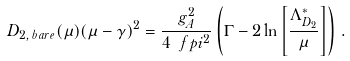<formula> <loc_0><loc_0><loc_500><loc_500>D _ { 2 , \, b a r e } ( \mu ) ( \mu - \gamma ) ^ { 2 } = \frac { g _ { A } ^ { 2 } } { 4 \ f p i ^ { 2 } } \left ( \Gamma - 2 \ln \left [ \frac { \Lambda ^ { * } _ { D _ { 2 } } } { \mu } \right ] \right ) \, .</formula> 